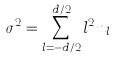<formula> <loc_0><loc_0><loc_500><loc_500>\sigma ^ { 2 } = \sum _ { l = - d / 2 } ^ { d / 2 } l ^ { 2 } n _ { l }</formula> 